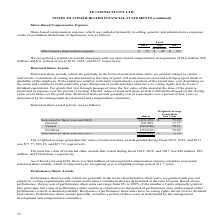According to Te Connectivity's financial document, What was the weighted-average grant-date fair value of restricted share awards granted during fiscal 2019? According to the financial document, $77.77. The relevant text states: "was $77.77, $93.45, and $67.72, respectively...." Also, What was the total fair value of restricted share awards that vested during fiscal 2019? According to the financial document, $48 million. The relevant text states: "that vested during fiscal 2019, 2018, and 2017 was $48 million, $50..." Also, What were the components of restricted share award activity under Nonvested at fiscal year end 2018 in the table? The document contains multiple relevant values: Granted, Vested, Forfeited. From the document: "Forfeited (232,910) 78.80 Granted 692,899 77.77 Nonvested at fiscal year end 2018 1,631,470 $ 75.39..." Additionally, In which year was the weighted-average grant-date fair value of restricted share awards granted the largest? According to the financial document, 2018. The relevant text states: "2019 2018 2017..." Also, can you calculate: What was the change in the Weighted-Average Grant-Date Fair Value for nonvested shares in 2019 from 2018? Based on the calculation: $78.36-$75.39, the result is 2.97. This is based on the information: "Nonvested at fiscal year end 2018 1,631,470 $ 75.39 Nonvested at fiscal year end 2019 1,402,419 $ 78.36..." The key data points involved are: 75.39, 78.36. Also, can you calculate: What was the percentage change in the Weighted-Average Grant-Date Fair Value for nonvested shares in 2019 from 2018? To answer this question, I need to perform calculations using the financial data. The calculation is: ($78.36-$75.39)/$75.39, which equals 3.94 (percentage). This is based on the information: "Nonvested at fiscal year end 2018 1,631,470 $ 75.39 Nonvested at fiscal year end 2019 1,402,419 $ 78.36..." The key data points involved are: 75.39, 78.36. 